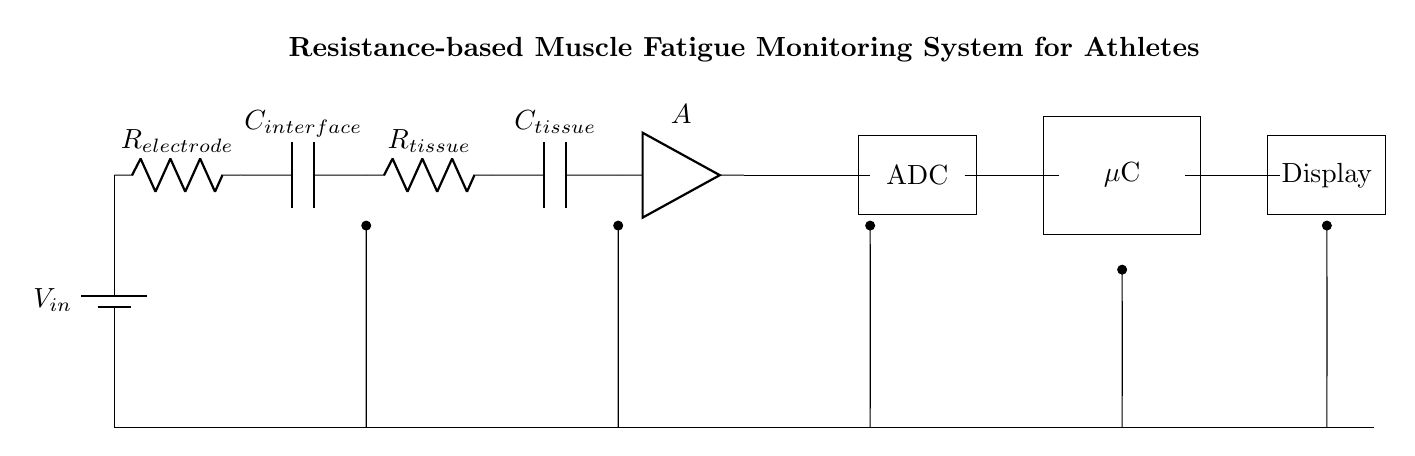What is the input voltage in this circuit? The input voltage is labeled as \( V_{in} \), typically representing the power supply voltage for the circuit components.
Answer: \( V_{in} \) What type of component is \( R_{tissue} \)? \( R_{tissue} \) is identified as a resistor in the circuit diagram, representing the resistance of muscle tissue in the monitoring system.
Answer: Resistor How many capacitors are present in the circuit? The circuit diagram has two capacitors, \( C_{interface} \) and \( C_{tissue} \), which are used for filtering or stabilization in the circuit.
Answer: 2 What role does the amplifier \( A \) play in this circuit? The amplifier \( A \) boosts the electrical signal coming from the tissue to a higher level, making it suitable for processing and conversion into digital data.
Answer: Signal amplification What is the output of the ADC? The output of the ADC converts the amplified analog signal from the amplifier into a digital format for further processing by the microcontroller.
Answer: Digital signal How are the components connected in this circuit? The components are connected in a series configuration, meaning that the current flows through each component one after another, forming a single pathway.
Answer: Series configuration What displays the final readings from the system? The final readings processed by the microcontroller are displayed on a device identified as the "Display" in the circuit diagram, which shows the fatigue monitoring results.
Answer: Display 